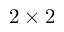<formula> <loc_0><loc_0><loc_500><loc_500>2 \times 2</formula> 